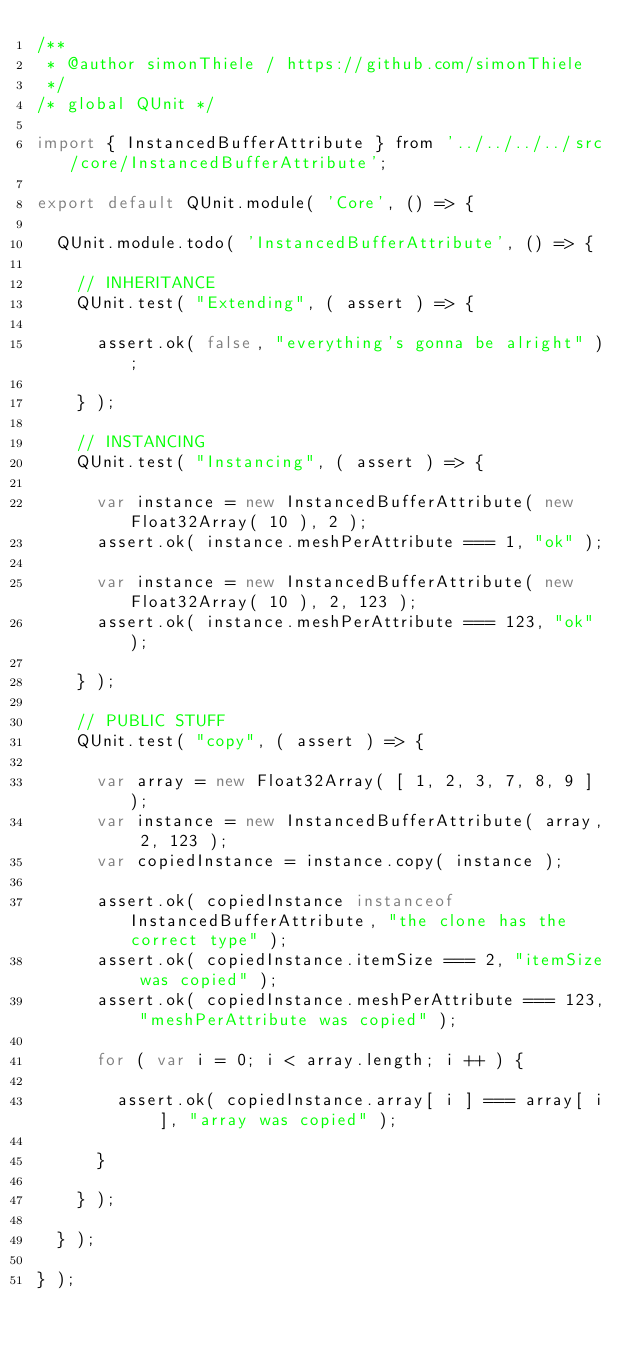Convert code to text. <code><loc_0><loc_0><loc_500><loc_500><_JavaScript_>/**
 * @author simonThiele / https://github.com/simonThiele
 */
/* global QUnit */

import { InstancedBufferAttribute } from '../../../../src/core/InstancedBufferAttribute';

export default QUnit.module( 'Core', () => {

	QUnit.module.todo( 'InstancedBufferAttribute', () => {

		// INHERITANCE
		QUnit.test( "Extending", ( assert ) => {

			assert.ok( false, "everything's gonna be alright" );

		} );

		// INSTANCING
		QUnit.test( "Instancing", ( assert ) => {

			var instance = new InstancedBufferAttribute( new Float32Array( 10 ), 2 );
			assert.ok( instance.meshPerAttribute === 1, "ok" );

			var instance = new InstancedBufferAttribute( new Float32Array( 10 ), 2, 123 );
			assert.ok( instance.meshPerAttribute === 123, "ok" );

		} );

		// PUBLIC STUFF
		QUnit.test( "copy", ( assert ) => {

			var array = new Float32Array( [ 1, 2, 3, 7, 8, 9 ] );
			var instance = new InstancedBufferAttribute( array, 2, 123 );
			var copiedInstance = instance.copy( instance );

			assert.ok( copiedInstance instanceof InstancedBufferAttribute, "the clone has the correct type" );
			assert.ok( copiedInstance.itemSize === 2, "itemSize was copied" );
			assert.ok( copiedInstance.meshPerAttribute === 123, "meshPerAttribute was copied" );

			for ( var i = 0; i < array.length; i ++ ) {

				assert.ok( copiedInstance.array[ i ] === array[ i ], "array was copied" );

			}

		} );

	} );

} );
</code> 